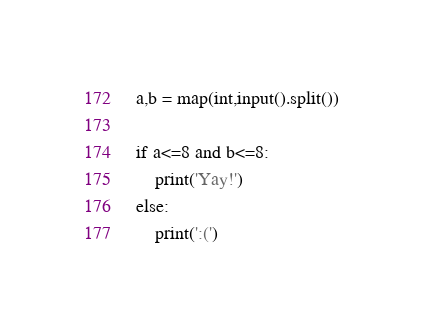<code> <loc_0><loc_0><loc_500><loc_500><_Python_>a,b = map(int,input().split())

if a<=8 and b<=8:
    print('Yay!')
else:
    print(':(')</code> 